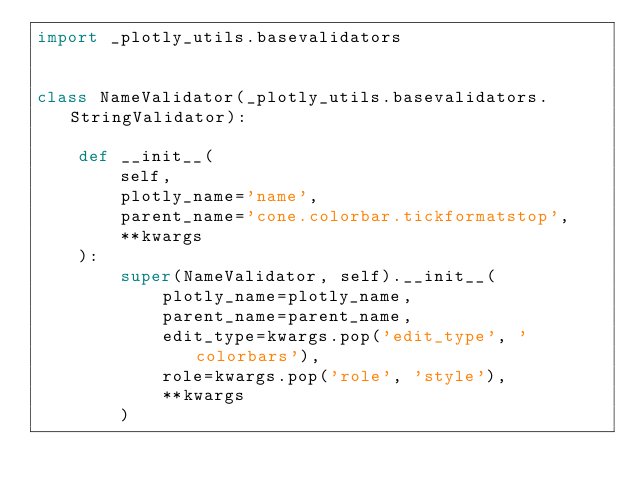Convert code to text. <code><loc_0><loc_0><loc_500><loc_500><_Python_>import _plotly_utils.basevalidators


class NameValidator(_plotly_utils.basevalidators.StringValidator):

    def __init__(
        self,
        plotly_name='name',
        parent_name='cone.colorbar.tickformatstop',
        **kwargs
    ):
        super(NameValidator, self).__init__(
            plotly_name=plotly_name,
            parent_name=parent_name,
            edit_type=kwargs.pop('edit_type', 'colorbars'),
            role=kwargs.pop('role', 'style'),
            **kwargs
        )
</code> 